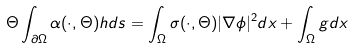Convert formula to latex. <formula><loc_0><loc_0><loc_500><loc_500>\Theta \int _ { \partial \Omega } \alpha ( \cdot , \Theta ) h d s = \int _ { \Omega } \sigma ( \cdot , \Theta ) | \nabla \phi | ^ { 2 } d x + \int _ { \Omega } g d x</formula> 